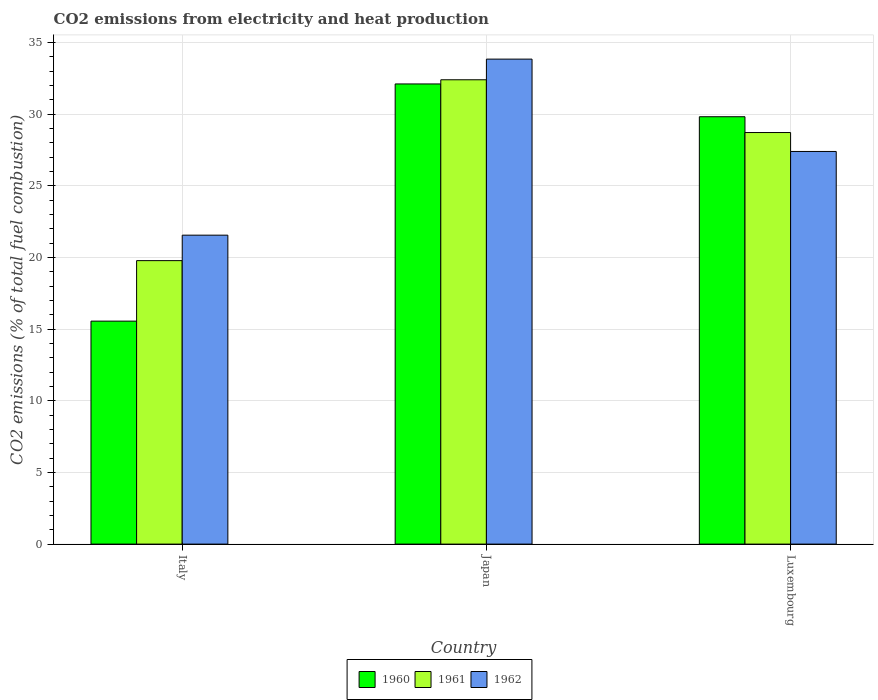How many different coloured bars are there?
Your answer should be compact. 3. How many bars are there on the 2nd tick from the left?
Make the answer very short. 3. How many bars are there on the 3rd tick from the right?
Make the answer very short. 3. What is the label of the 3rd group of bars from the left?
Provide a short and direct response. Luxembourg. What is the amount of CO2 emitted in 1961 in Japan?
Give a very brief answer. 32.39. Across all countries, what is the maximum amount of CO2 emitted in 1960?
Offer a very short reply. 32.1. Across all countries, what is the minimum amount of CO2 emitted in 1961?
Your answer should be compact. 19.78. In which country was the amount of CO2 emitted in 1962 minimum?
Your response must be concise. Italy. What is the total amount of CO2 emitted in 1960 in the graph?
Your answer should be compact. 77.47. What is the difference between the amount of CO2 emitted in 1961 in Italy and that in Luxembourg?
Your answer should be compact. -8.93. What is the difference between the amount of CO2 emitted in 1960 in Japan and the amount of CO2 emitted in 1961 in Italy?
Offer a very short reply. 12.33. What is the average amount of CO2 emitted in 1960 per country?
Your answer should be compact. 25.82. What is the difference between the amount of CO2 emitted of/in 1960 and amount of CO2 emitted of/in 1962 in Italy?
Make the answer very short. -6. What is the ratio of the amount of CO2 emitted in 1961 in Italy to that in Japan?
Ensure brevity in your answer.  0.61. Is the amount of CO2 emitted in 1961 in Japan less than that in Luxembourg?
Provide a succinct answer. No. Is the difference between the amount of CO2 emitted in 1960 in Japan and Luxembourg greater than the difference between the amount of CO2 emitted in 1962 in Japan and Luxembourg?
Make the answer very short. No. What is the difference between the highest and the second highest amount of CO2 emitted in 1961?
Make the answer very short. 12.62. What is the difference between the highest and the lowest amount of CO2 emitted in 1960?
Your answer should be very brief. 16.55. In how many countries, is the amount of CO2 emitted in 1962 greater than the average amount of CO2 emitted in 1962 taken over all countries?
Provide a succinct answer. 1. What does the 2nd bar from the right in Luxembourg represents?
Offer a terse response. 1961. Is it the case that in every country, the sum of the amount of CO2 emitted in 1960 and amount of CO2 emitted in 1961 is greater than the amount of CO2 emitted in 1962?
Your answer should be very brief. Yes. Are all the bars in the graph horizontal?
Make the answer very short. No. How many countries are there in the graph?
Give a very brief answer. 3. Are the values on the major ticks of Y-axis written in scientific E-notation?
Your response must be concise. No. Does the graph contain any zero values?
Offer a terse response. No. Where does the legend appear in the graph?
Make the answer very short. Bottom center. How many legend labels are there?
Provide a short and direct response. 3. What is the title of the graph?
Make the answer very short. CO2 emissions from electricity and heat production. What is the label or title of the Y-axis?
Provide a short and direct response. CO2 emissions (% of total fuel combustion). What is the CO2 emissions (% of total fuel combustion) in 1960 in Italy?
Your response must be concise. 15.55. What is the CO2 emissions (% of total fuel combustion) of 1961 in Italy?
Your answer should be very brief. 19.78. What is the CO2 emissions (% of total fuel combustion) of 1962 in Italy?
Offer a terse response. 21.55. What is the CO2 emissions (% of total fuel combustion) in 1960 in Japan?
Provide a short and direct response. 32.1. What is the CO2 emissions (% of total fuel combustion) of 1961 in Japan?
Give a very brief answer. 32.39. What is the CO2 emissions (% of total fuel combustion) in 1962 in Japan?
Provide a short and direct response. 33.83. What is the CO2 emissions (% of total fuel combustion) of 1960 in Luxembourg?
Ensure brevity in your answer.  29.81. What is the CO2 emissions (% of total fuel combustion) in 1961 in Luxembourg?
Keep it short and to the point. 28.71. What is the CO2 emissions (% of total fuel combustion) of 1962 in Luxembourg?
Provide a succinct answer. 27.39. Across all countries, what is the maximum CO2 emissions (% of total fuel combustion) in 1960?
Offer a very short reply. 32.1. Across all countries, what is the maximum CO2 emissions (% of total fuel combustion) of 1961?
Provide a short and direct response. 32.39. Across all countries, what is the maximum CO2 emissions (% of total fuel combustion) of 1962?
Your answer should be compact. 33.83. Across all countries, what is the minimum CO2 emissions (% of total fuel combustion) of 1960?
Offer a terse response. 15.55. Across all countries, what is the minimum CO2 emissions (% of total fuel combustion) of 1961?
Offer a terse response. 19.78. Across all countries, what is the minimum CO2 emissions (% of total fuel combustion) of 1962?
Ensure brevity in your answer.  21.55. What is the total CO2 emissions (% of total fuel combustion) of 1960 in the graph?
Offer a terse response. 77.47. What is the total CO2 emissions (% of total fuel combustion) of 1961 in the graph?
Ensure brevity in your answer.  80.88. What is the total CO2 emissions (% of total fuel combustion) of 1962 in the graph?
Give a very brief answer. 82.78. What is the difference between the CO2 emissions (% of total fuel combustion) of 1960 in Italy and that in Japan?
Give a very brief answer. -16.55. What is the difference between the CO2 emissions (% of total fuel combustion) of 1961 in Italy and that in Japan?
Your response must be concise. -12.62. What is the difference between the CO2 emissions (% of total fuel combustion) of 1962 in Italy and that in Japan?
Your answer should be compact. -12.28. What is the difference between the CO2 emissions (% of total fuel combustion) in 1960 in Italy and that in Luxembourg?
Your answer should be very brief. -14.26. What is the difference between the CO2 emissions (% of total fuel combustion) of 1961 in Italy and that in Luxembourg?
Provide a short and direct response. -8.93. What is the difference between the CO2 emissions (% of total fuel combustion) of 1962 in Italy and that in Luxembourg?
Your answer should be very brief. -5.84. What is the difference between the CO2 emissions (% of total fuel combustion) in 1960 in Japan and that in Luxembourg?
Your answer should be compact. 2.29. What is the difference between the CO2 emissions (% of total fuel combustion) in 1961 in Japan and that in Luxembourg?
Your response must be concise. 3.68. What is the difference between the CO2 emissions (% of total fuel combustion) in 1962 in Japan and that in Luxembourg?
Ensure brevity in your answer.  6.44. What is the difference between the CO2 emissions (% of total fuel combustion) of 1960 in Italy and the CO2 emissions (% of total fuel combustion) of 1961 in Japan?
Your response must be concise. -16.84. What is the difference between the CO2 emissions (% of total fuel combustion) of 1960 in Italy and the CO2 emissions (% of total fuel combustion) of 1962 in Japan?
Give a very brief answer. -18.28. What is the difference between the CO2 emissions (% of total fuel combustion) in 1961 in Italy and the CO2 emissions (% of total fuel combustion) in 1962 in Japan?
Keep it short and to the point. -14.06. What is the difference between the CO2 emissions (% of total fuel combustion) of 1960 in Italy and the CO2 emissions (% of total fuel combustion) of 1961 in Luxembourg?
Your answer should be compact. -13.16. What is the difference between the CO2 emissions (% of total fuel combustion) of 1960 in Italy and the CO2 emissions (% of total fuel combustion) of 1962 in Luxembourg?
Your answer should be very brief. -11.84. What is the difference between the CO2 emissions (% of total fuel combustion) of 1961 in Italy and the CO2 emissions (% of total fuel combustion) of 1962 in Luxembourg?
Give a very brief answer. -7.62. What is the difference between the CO2 emissions (% of total fuel combustion) of 1960 in Japan and the CO2 emissions (% of total fuel combustion) of 1961 in Luxembourg?
Provide a succinct answer. 3.39. What is the difference between the CO2 emissions (% of total fuel combustion) in 1960 in Japan and the CO2 emissions (% of total fuel combustion) in 1962 in Luxembourg?
Your answer should be very brief. 4.71. What is the difference between the CO2 emissions (% of total fuel combustion) of 1961 in Japan and the CO2 emissions (% of total fuel combustion) of 1962 in Luxembourg?
Keep it short and to the point. 5. What is the average CO2 emissions (% of total fuel combustion) of 1960 per country?
Provide a short and direct response. 25.82. What is the average CO2 emissions (% of total fuel combustion) of 1961 per country?
Make the answer very short. 26.96. What is the average CO2 emissions (% of total fuel combustion) in 1962 per country?
Provide a succinct answer. 27.59. What is the difference between the CO2 emissions (% of total fuel combustion) in 1960 and CO2 emissions (% of total fuel combustion) in 1961 in Italy?
Your answer should be very brief. -4.22. What is the difference between the CO2 emissions (% of total fuel combustion) of 1960 and CO2 emissions (% of total fuel combustion) of 1962 in Italy?
Your answer should be very brief. -6. What is the difference between the CO2 emissions (% of total fuel combustion) in 1961 and CO2 emissions (% of total fuel combustion) in 1962 in Italy?
Keep it short and to the point. -1.78. What is the difference between the CO2 emissions (% of total fuel combustion) in 1960 and CO2 emissions (% of total fuel combustion) in 1961 in Japan?
Your answer should be compact. -0.29. What is the difference between the CO2 emissions (% of total fuel combustion) in 1960 and CO2 emissions (% of total fuel combustion) in 1962 in Japan?
Make the answer very short. -1.73. What is the difference between the CO2 emissions (% of total fuel combustion) of 1961 and CO2 emissions (% of total fuel combustion) of 1962 in Japan?
Provide a succinct answer. -1.44. What is the difference between the CO2 emissions (% of total fuel combustion) in 1960 and CO2 emissions (% of total fuel combustion) in 1961 in Luxembourg?
Make the answer very short. 1.1. What is the difference between the CO2 emissions (% of total fuel combustion) of 1960 and CO2 emissions (% of total fuel combustion) of 1962 in Luxembourg?
Provide a short and direct response. 2.42. What is the difference between the CO2 emissions (% of total fuel combustion) in 1961 and CO2 emissions (% of total fuel combustion) in 1962 in Luxembourg?
Offer a terse response. 1.32. What is the ratio of the CO2 emissions (% of total fuel combustion) in 1960 in Italy to that in Japan?
Ensure brevity in your answer.  0.48. What is the ratio of the CO2 emissions (% of total fuel combustion) of 1961 in Italy to that in Japan?
Offer a terse response. 0.61. What is the ratio of the CO2 emissions (% of total fuel combustion) in 1962 in Italy to that in Japan?
Provide a short and direct response. 0.64. What is the ratio of the CO2 emissions (% of total fuel combustion) of 1960 in Italy to that in Luxembourg?
Provide a succinct answer. 0.52. What is the ratio of the CO2 emissions (% of total fuel combustion) of 1961 in Italy to that in Luxembourg?
Offer a terse response. 0.69. What is the ratio of the CO2 emissions (% of total fuel combustion) in 1962 in Italy to that in Luxembourg?
Offer a terse response. 0.79. What is the ratio of the CO2 emissions (% of total fuel combustion) of 1960 in Japan to that in Luxembourg?
Provide a short and direct response. 1.08. What is the ratio of the CO2 emissions (% of total fuel combustion) of 1961 in Japan to that in Luxembourg?
Keep it short and to the point. 1.13. What is the ratio of the CO2 emissions (% of total fuel combustion) of 1962 in Japan to that in Luxembourg?
Keep it short and to the point. 1.24. What is the difference between the highest and the second highest CO2 emissions (% of total fuel combustion) in 1960?
Offer a very short reply. 2.29. What is the difference between the highest and the second highest CO2 emissions (% of total fuel combustion) in 1961?
Provide a succinct answer. 3.68. What is the difference between the highest and the second highest CO2 emissions (% of total fuel combustion) of 1962?
Your answer should be very brief. 6.44. What is the difference between the highest and the lowest CO2 emissions (% of total fuel combustion) in 1960?
Your answer should be compact. 16.55. What is the difference between the highest and the lowest CO2 emissions (% of total fuel combustion) of 1961?
Give a very brief answer. 12.62. What is the difference between the highest and the lowest CO2 emissions (% of total fuel combustion) in 1962?
Offer a terse response. 12.28. 